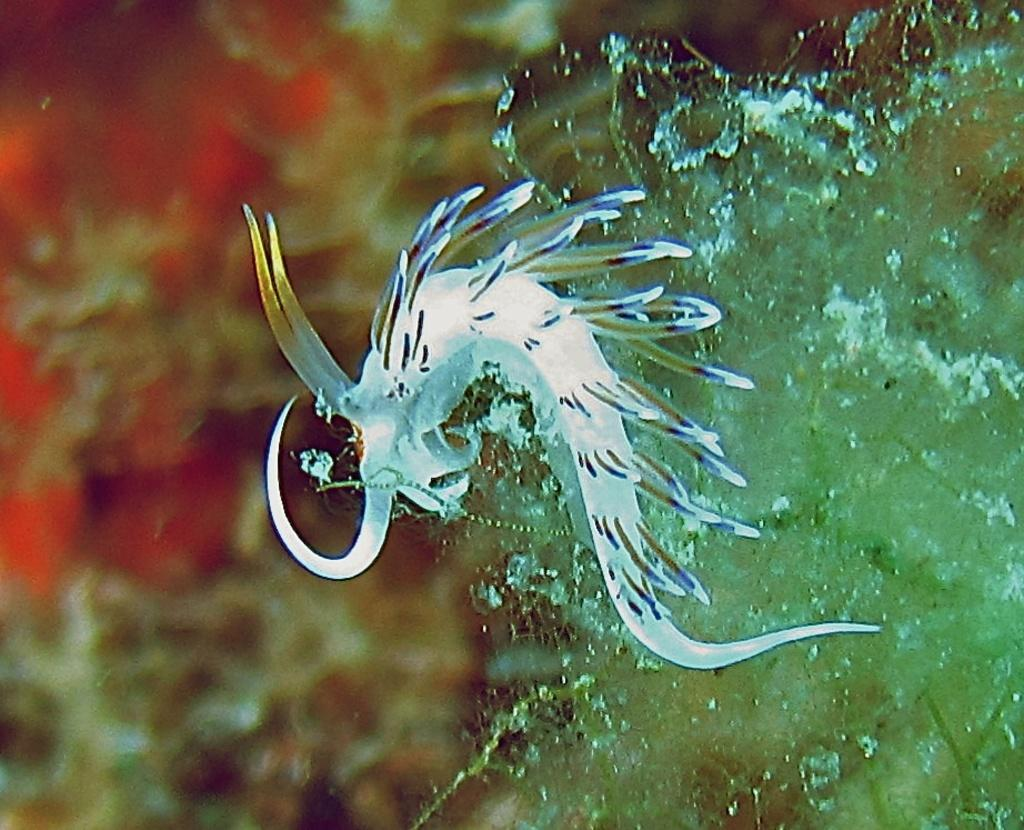What is the primary element visible in the image? There is water visible in the image. Can you describe the white object in the image? There is a white color thing in the image. What type of list can be seen in the image? There is no list present in the image; it only contains water and a white object. 